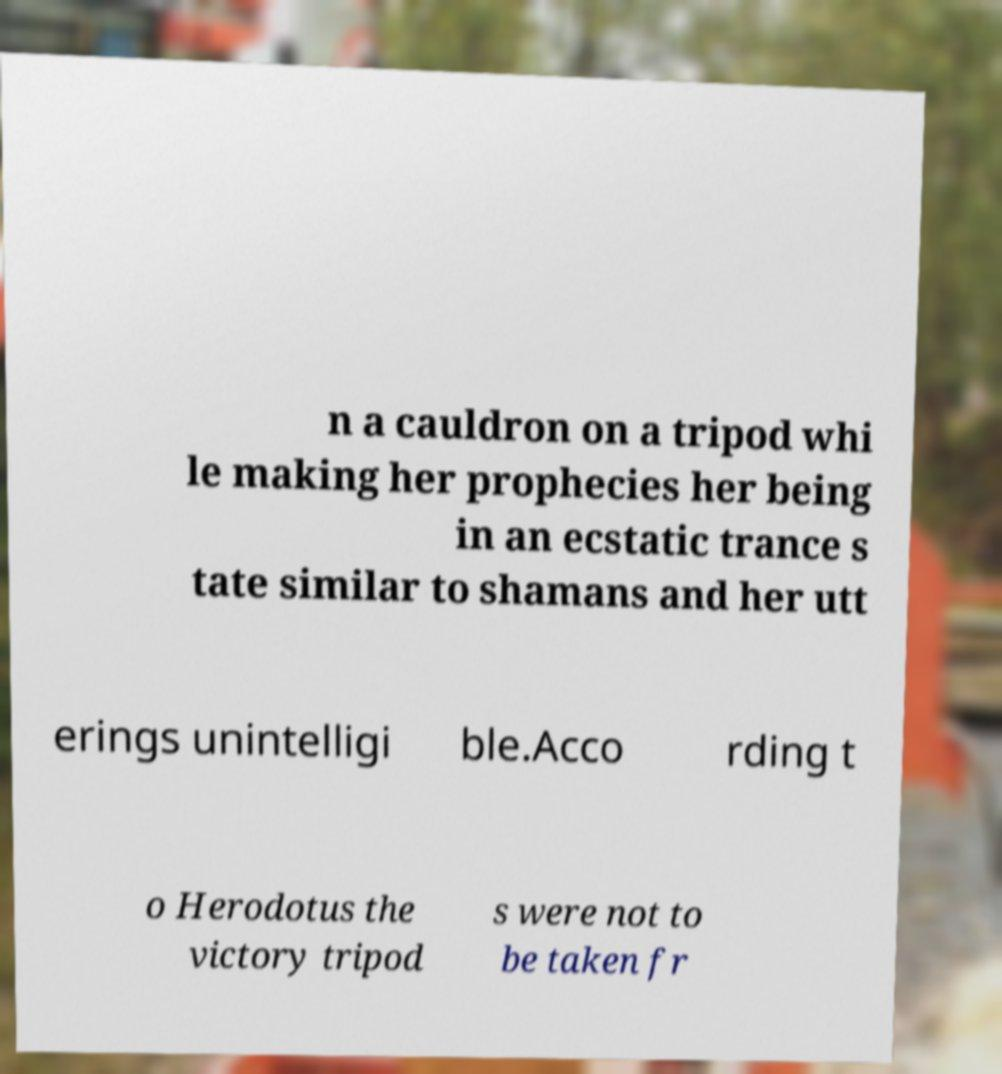Could you extract and type out the text from this image? n a cauldron on a tripod whi le making her prophecies her being in an ecstatic trance s tate similar to shamans and her utt erings unintelligi ble.Acco rding t o Herodotus the victory tripod s were not to be taken fr 